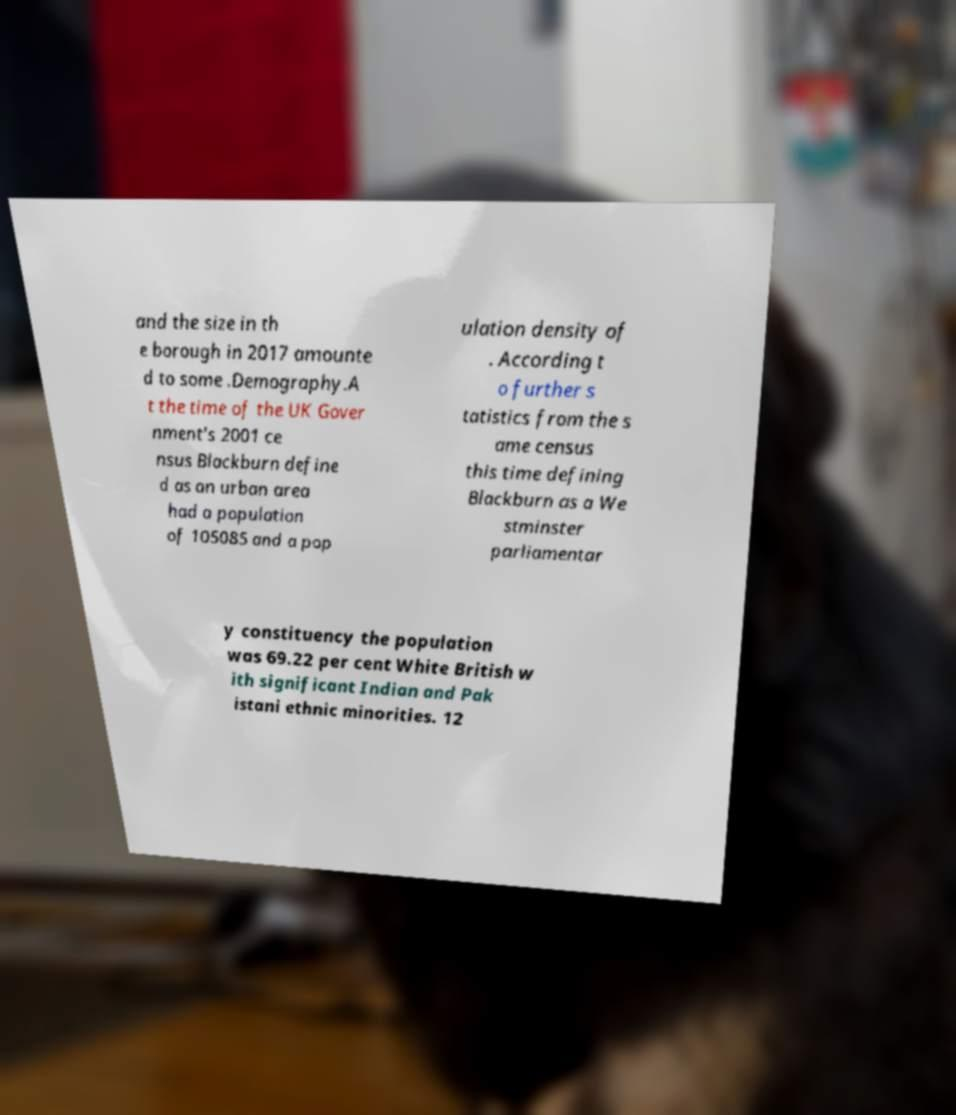For documentation purposes, I need the text within this image transcribed. Could you provide that? and the size in th e borough in 2017 amounte d to some .Demography.A t the time of the UK Gover nment's 2001 ce nsus Blackburn define d as an urban area had a population of 105085 and a pop ulation density of . According t o further s tatistics from the s ame census this time defining Blackburn as a We stminster parliamentar y constituency the population was 69.22 per cent White British w ith significant Indian and Pak istani ethnic minorities. 12 